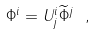<formula> <loc_0><loc_0><loc_500><loc_500>\Phi ^ { i } = U ^ { i } _ { j } { \widetilde { \Phi } } ^ { j } \ ,</formula> 